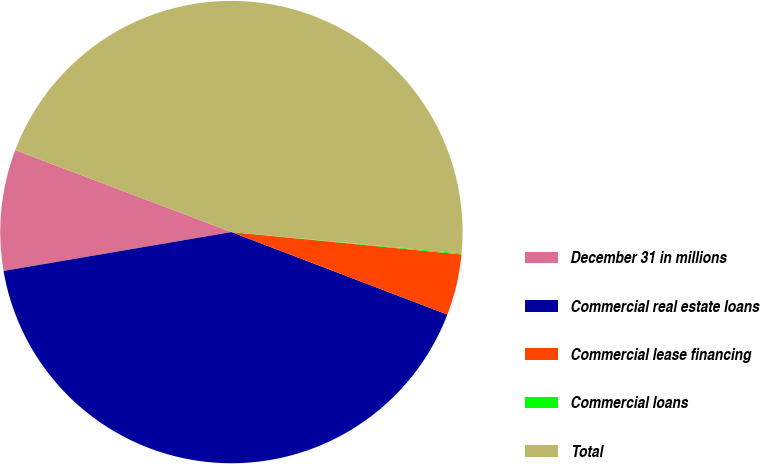Convert chart to OTSL. <chart><loc_0><loc_0><loc_500><loc_500><pie_chart><fcel>December 31 in millions<fcel>Commercial real estate loans<fcel>Commercial lease financing<fcel>Commercial loans<fcel>Total<nl><fcel>8.46%<fcel>41.51%<fcel>4.26%<fcel>0.07%<fcel>45.71%<nl></chart> 